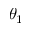<formula> <loc_0><loc_0><loc_500><loc_500>\theta _ { 1 }</formula> 